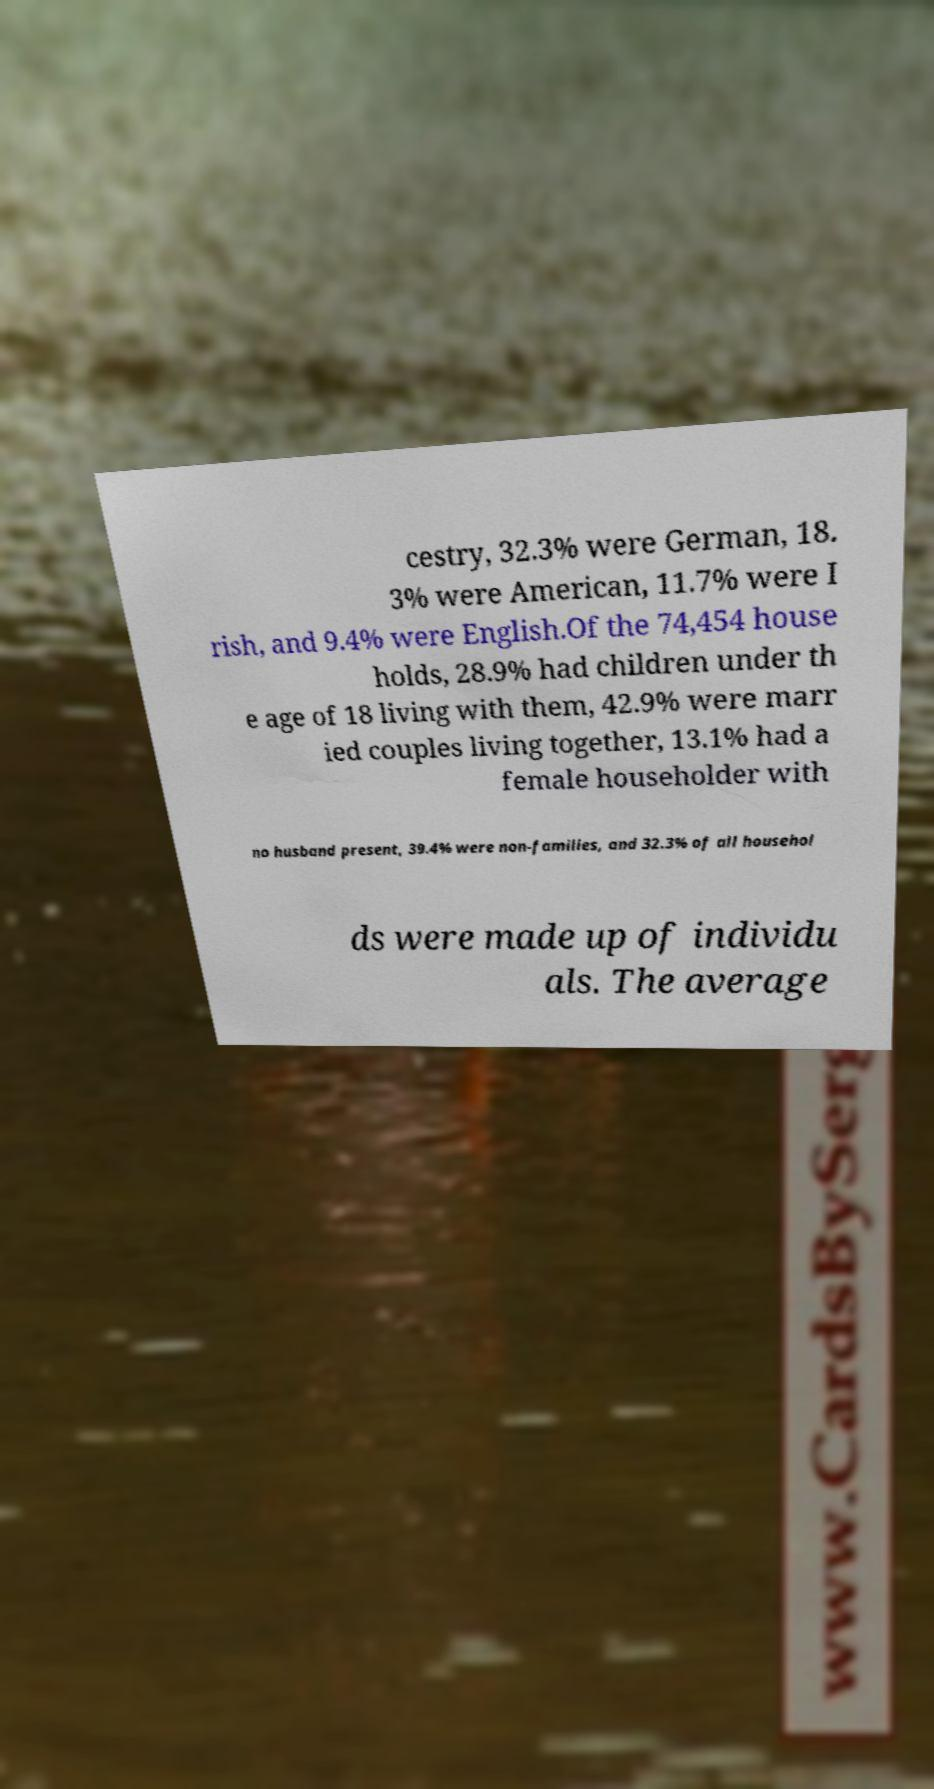Could you extract and type out the text from this image? cestry, 32.3% were German, 18. 3% were American, 11.7% were I rish, and 9.4% were English.Of the 74,454 house holds, 28.9% had children under th e age of 18 living with them, 42.9% were marr ied couples living together, 13.1% had a female householder with no husband present, 39.4% were non-families, and 32.3% of all househol ds were made up of individu als. The average 